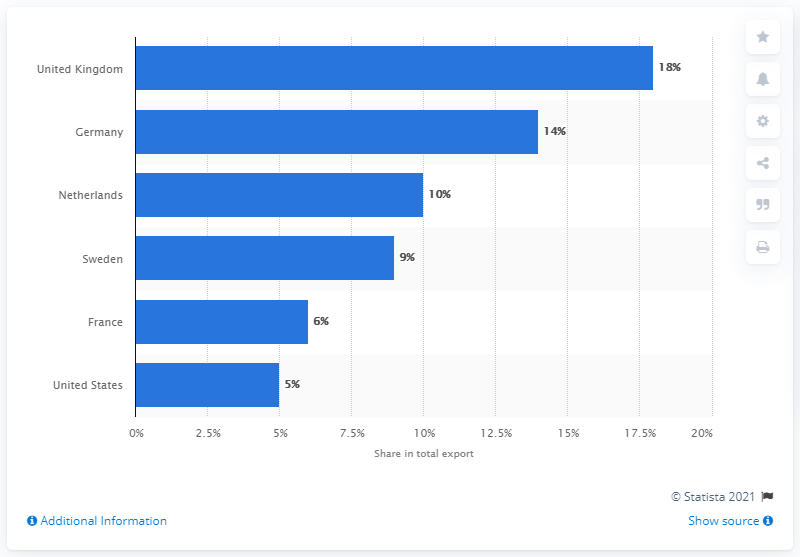Indicate a few pertinent items in this graphic. In 2019, Norway's most significant export partner was the United Kingdom. 